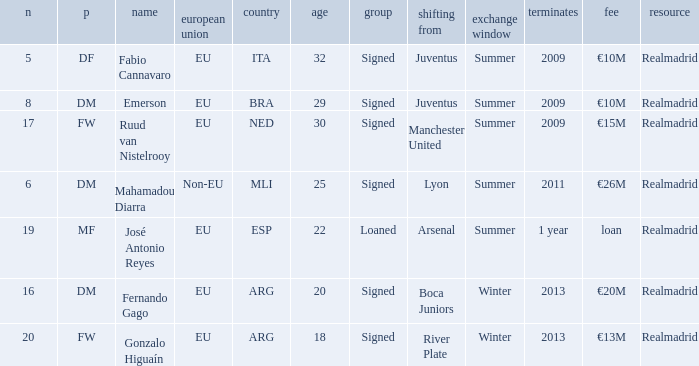How many numbers are ending in 1 year? 1.0. 